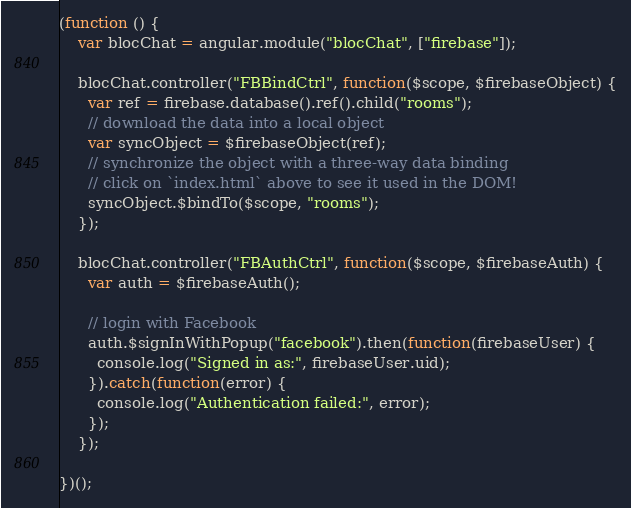Convert code to text. <code><loc_0><loc_0><loc_500><loc_500><_JavaScript_>(function () {
    var blocChat = angular.module("blocChat", ["firebase"]);
    
    blocChat.controller("FBBindCtrl", function($scope, $firebaseObject) {
      var ref = firebase.database().ref().child("rooms");
      // download the data into a local object
      var syncObject = $firebaseObject(ref);
      // synchronize the object with a three-way data binding
      // click on `index.html` above to see it used in the DOM!
      syncObject.$bindTo($scope, "rooms");
    });
    
    blocChat.controller("FBAuthCtrl", function($scope, $firebaseAuth) {
      var auth = $firebaseAuth();

      // login with Facebook
      auth.$signInWithPopup("facebook").then(function(firebaseUser) {
        console.log("Signed in as:", firebaseUser.uid);
      }).catch(function(error) {
        console.log("Authentication failed:", error);
      });
    });

})();
</code> 